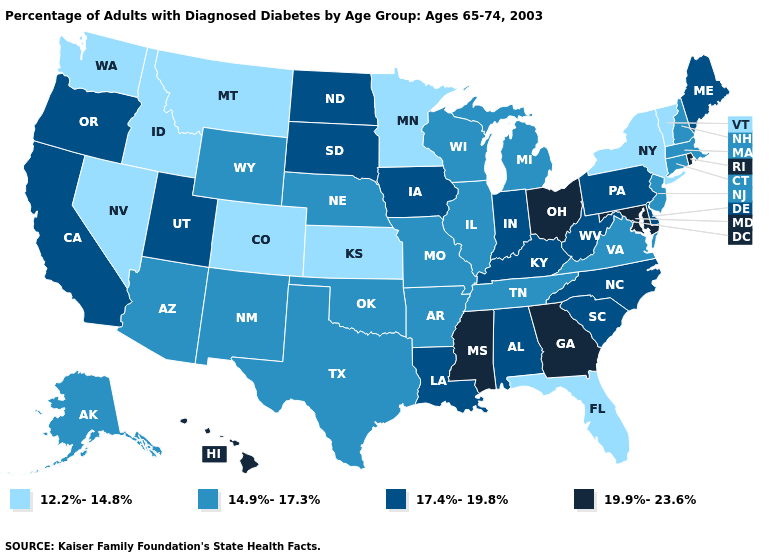Does Kansas have the lowest value in the USA?
Write a very short answer. Yes. Among the states that border Oklahoma , does Arkansas have the highest value?
Write a very short answer. Yes. Which states have the lowest value in the Northeast?
Answer briefly. New York, Vermont. Does Illinois have the lowest value in the MidWest?
Keep it brief. No. Name the states that have a value in the range 12.2%-14.8%?
Concise answer only. Colorado, Florida, Idaho, Kansas, Minnesota, Montana, Nevada, New York, Vermont, Washington. Which states have the lowest value in the USA?
Give a very brief answer. Colorado, Florida, Idaho, Kansas, Minnesota, Montana, Nevada, New York, Vermont, Washington. How many symbols are there in the legend?
Be succinct. 4. What is the value of New Mexico?
Give a very brief answer. 14.9%-17.3%. What is the value of Alaska?
Keep it brief. 14.9%-17.3%. What is the value of Nebraska?
Short answer required. 14.9%-17.3%. Does Hawaii have the lowest value in the USA?
Answer briefly. No. Name the states that have a value in the range 17.4%-19.8%?
Give a very brief answer. Alabama, California, Delaware, Indiana, Iowa, Kentucky, Louisiana, Maine, North Carolina, North Dakota, Oregon, Pennsylvania, South Carolina, South Dakota, Utah, West Virginia. Among the states that border Pennsylvania , does Delaware have the highest value?
Quick response, please. No. What is the lowest value in the USA?
Concise answer only. 12.2%-14.8%. Does Ohio have the highest value in the USA?
Be succinct. Yes. 